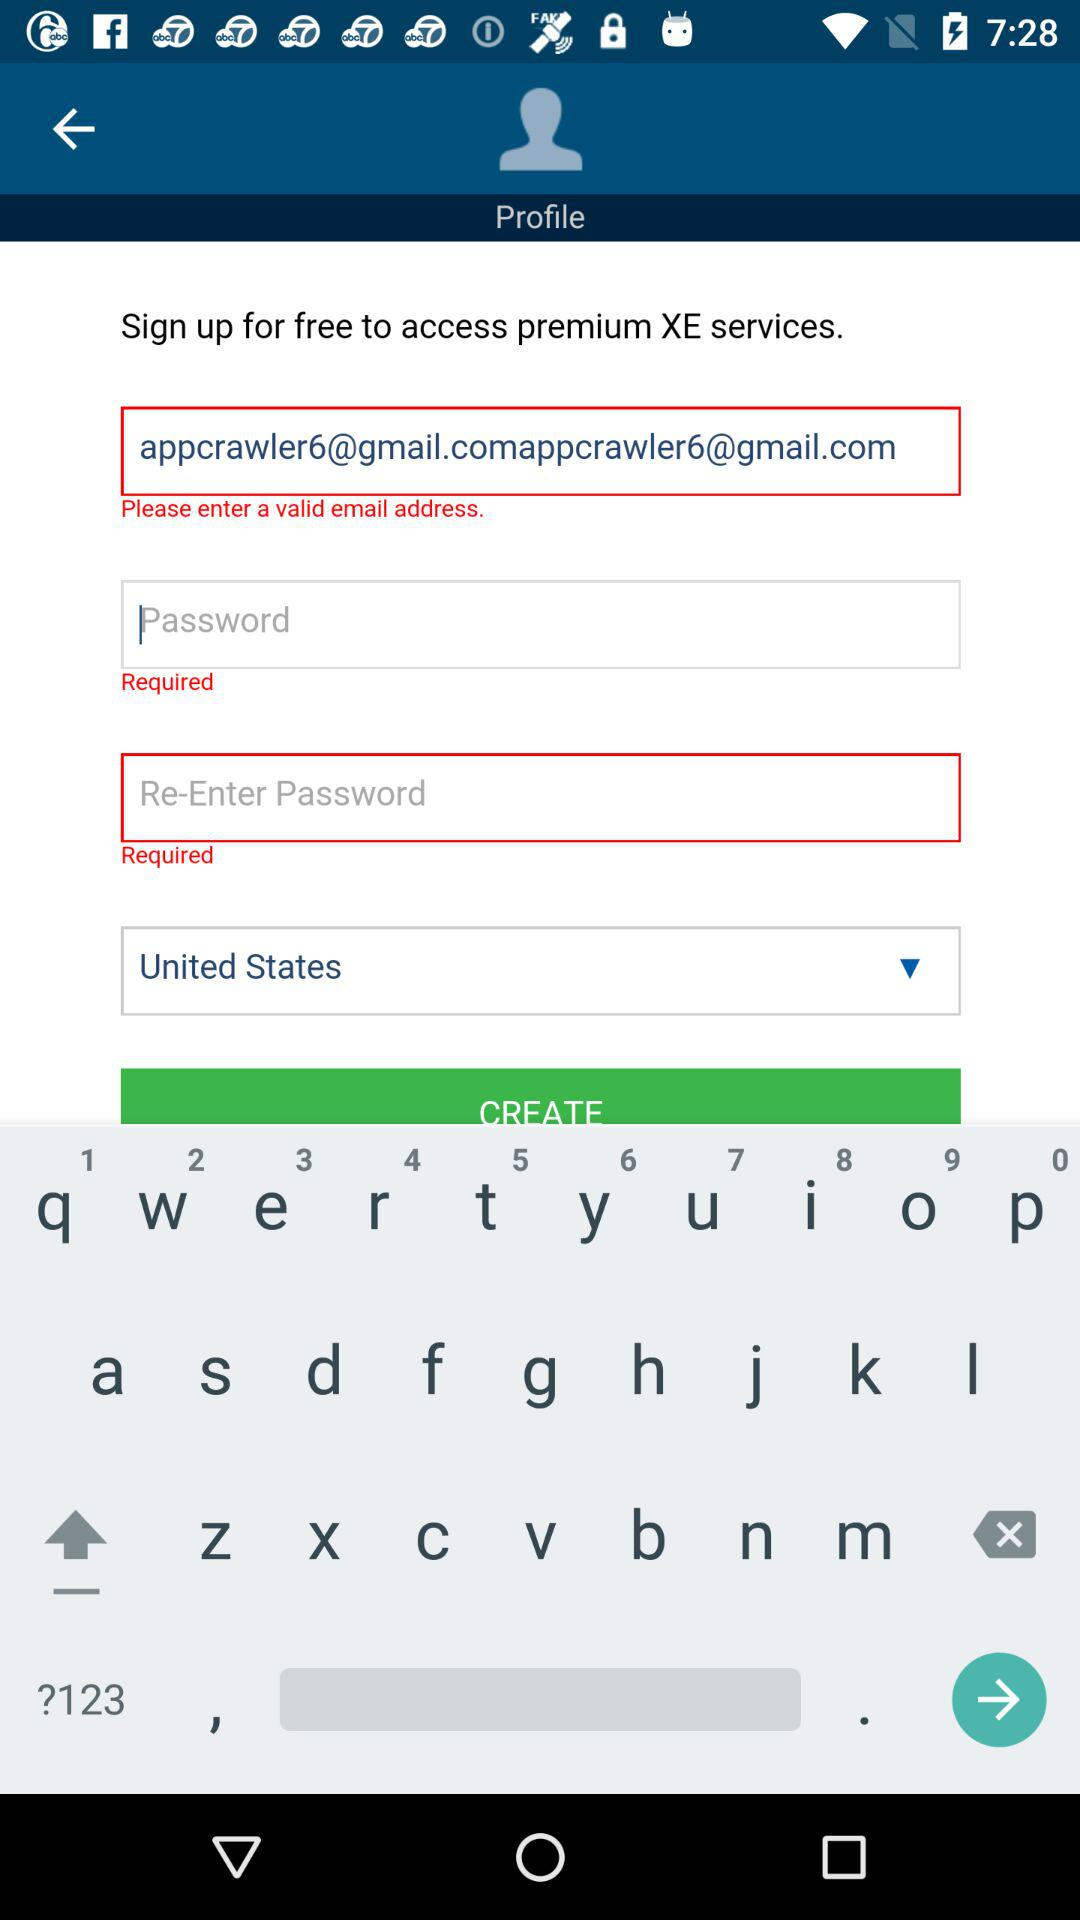How many required fields are there in the screenshot?
Answer the question using a single word or phrase. 3 